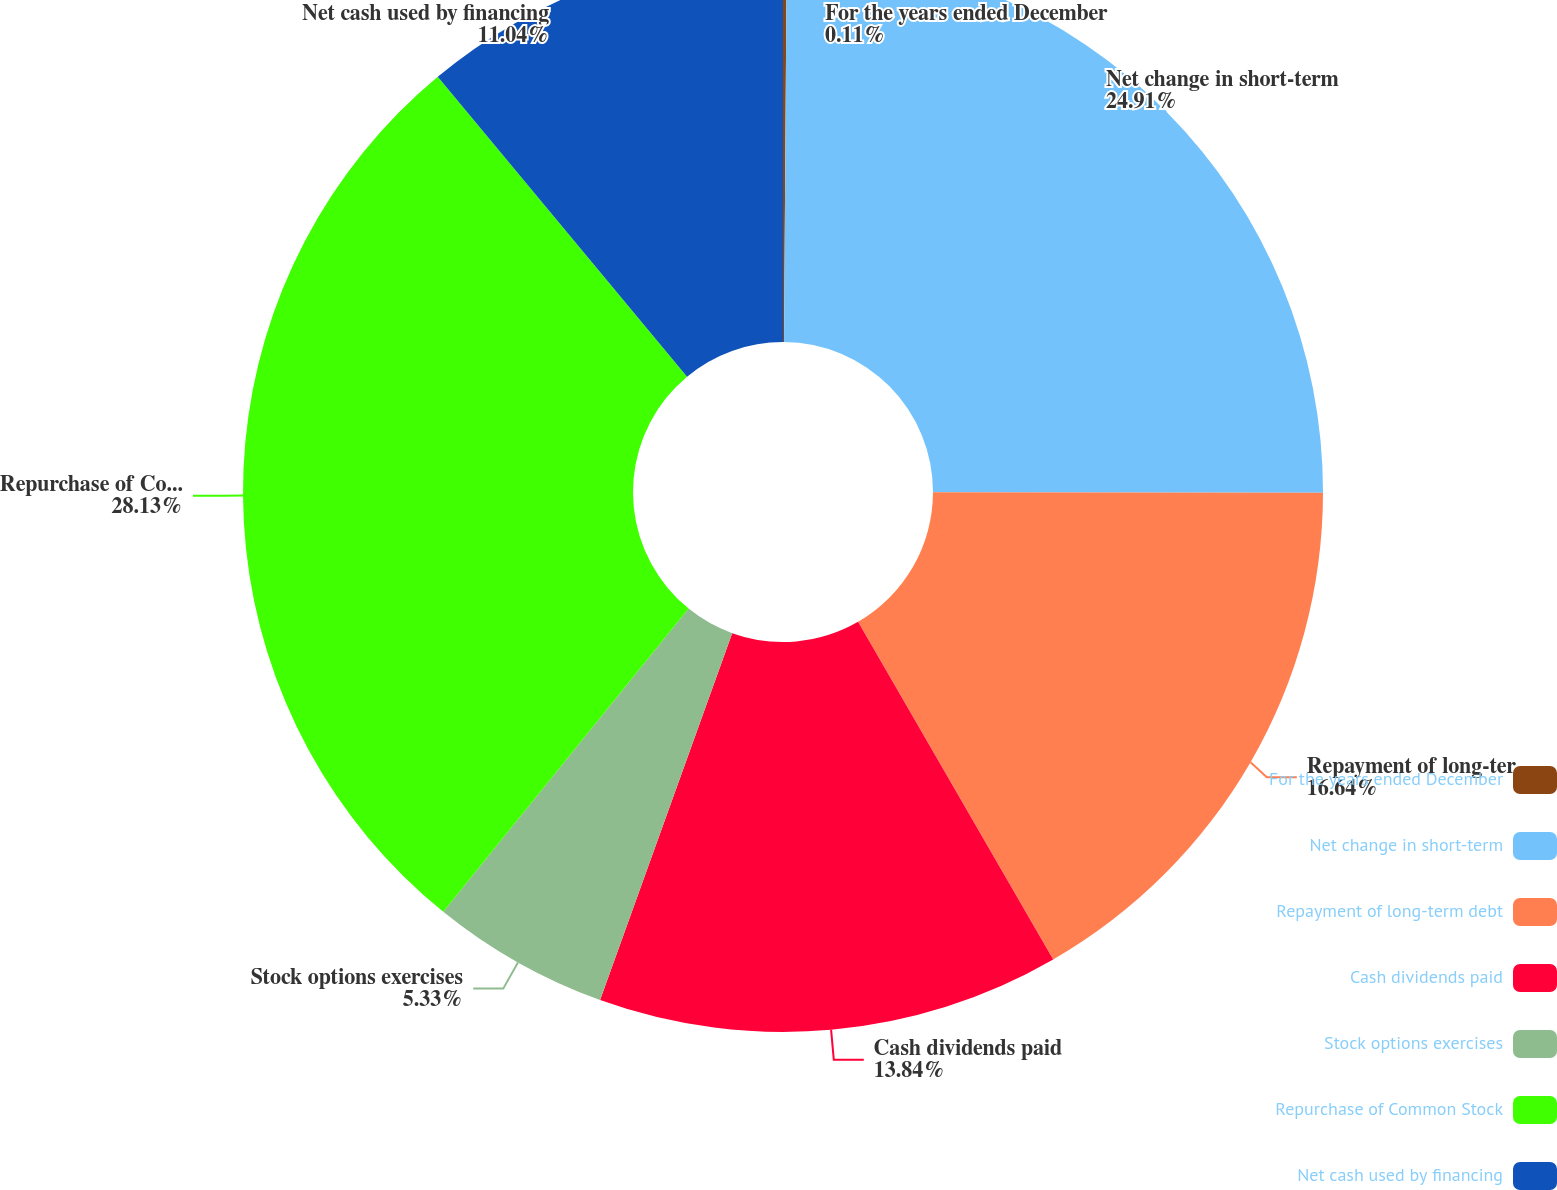<chart> <loc_0><loc_0><loc_500><loc_500><pie_chart><fcel>For the years ended December<fcel>Net change in short-term<fcel>Repayment of long-term debt<fcel>Cash dividends paid<fcel>Stock options exercises<fcel>Repurchase of Common Stock<fcel>Net cash used by financing<nl><fcel>0.11%<fcel>24.91%<fcel>16.64%<fcel>13.84%<fcel>5.33%<fcel>28.13%<fcel>11.04%<nl></chart> 